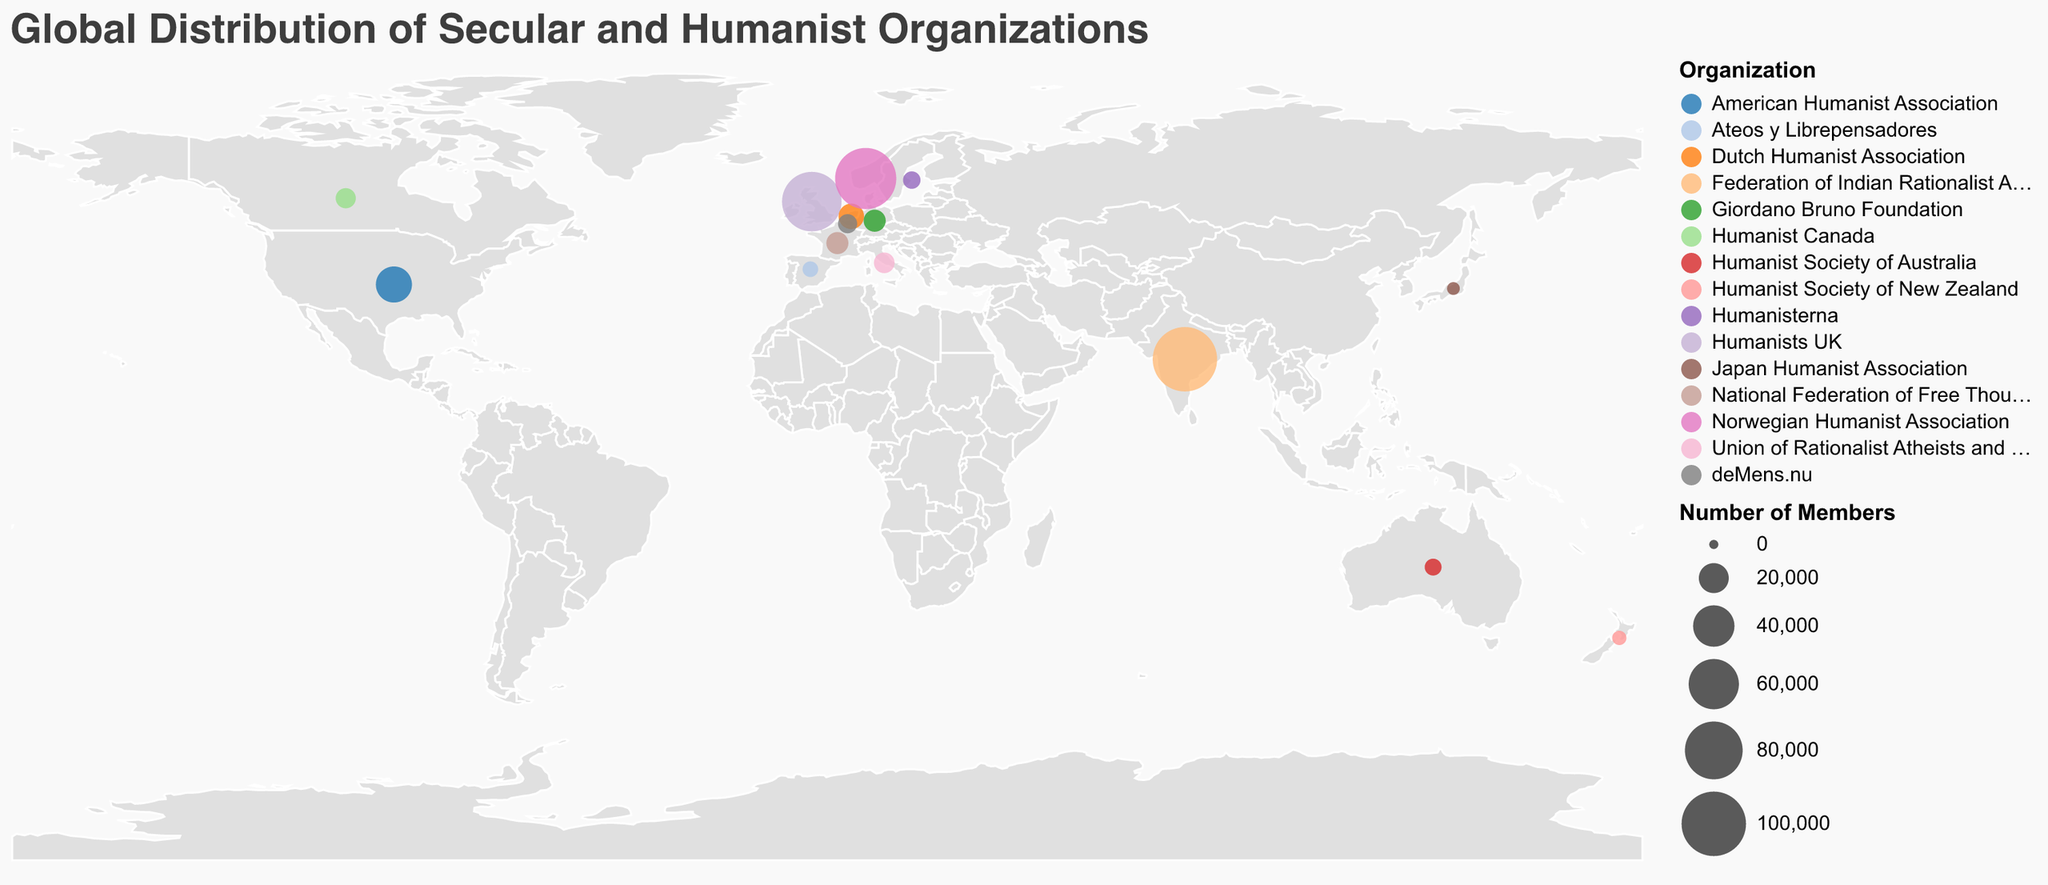What is the title of the figure? The title of the figure is displayed at the top and defines the content and scope of the plot.
Answer: Global Distribution of Secular and Humanist Organizations Which country has the organization with the highest number of members? By looking at the circle size representing the number of members, the largest circle appears in India. The tooltip confirms the organization and membership.
Answer: India How many countries have an organization with over 50,000 members? By observing the circles and checking the tooltips, there are two countries with organizations having over 50,000 members: India and Norway.
Answer: 2 Compare the number of members in the Humanist Society of Australia with the Humanist Society of New Zealand. Which has more members? By looking at the circles and using the tooltips, the Humanist Society of Australia has 5,000 members, and the Humanist Society of New Zealand has 3,000 members. Therefore, Australia has more members.
Answer: Australia What's the sum of the number of members for organizations in European countries only? First, identify European countries: United Kingdom, Netherlands, Germany, Norway, Belgium, France, Sweden, Italy, Spain. Sum their member counts: 85,000 + 14,000 + 10,000 + 90,000 + 7,000 + 10,000 + 5,500 + 8,500 + 4,000 = 234,000 members.
Answer: 234,000 Which organization represents Sweden and what is its member count? The circle located in Sweden can be identified through the tooltip, which informs that the organization is Humanisterna, with a membership of 5,500.
Answer: Humanisterna, 5,500 Which two countries have organizations with member counts closest to each other? Comparing the numbers in the tooltips, Germany (10,000 members) and France (10,000 members) have the closest member counts.
Answer: Germany and France What is the average number of members of all organizations represented in the plot? Sum the members of all organizations and divide by the number of countries: (30000 + 85000 + 14000 + 100000 + 5000 + 10000 + 8000 + 90000 + 7000 + 10000 + 5500 + 3000 + 8500 + 4000 + 2000) / 15. The total is 374,000 members; average is 374,000 / 15 = 24,933.33.
Answer: 24,933.33 Is there any continent without any organization representation in the plot, and if so, which one(s)? By examining the geographic spread of the circles on the plot, we can observe that Africa and Antarctica have no organization representations.
Answer: Africa and Antarctica 